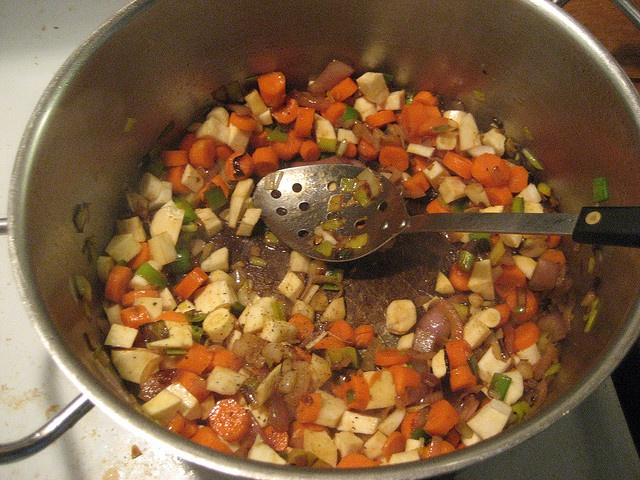Describe the objects in this image and their specific colors. I can see bowl in maroon, olive, gray, brown, and black tones, carrot in gray, brown, red, and maroon tones, spoon in gray, maroon, olive, and black tones, carrot in gray, brown, maroon, and red tones, and carrot in gray, brown, red, and maroon tones in this image. 